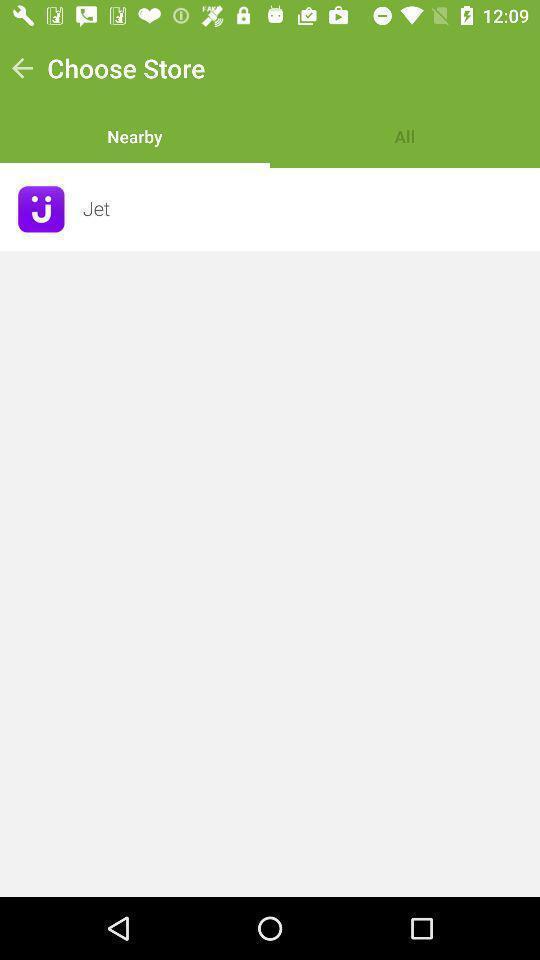Explain the elements present in this screenshot. Screen displaying to choose store. 